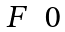Convert formula to latex. <formula><loc_0><loc_0><loc_500><loc_500>\begin{matrix} F & 0 \end{matrix}</formula> 